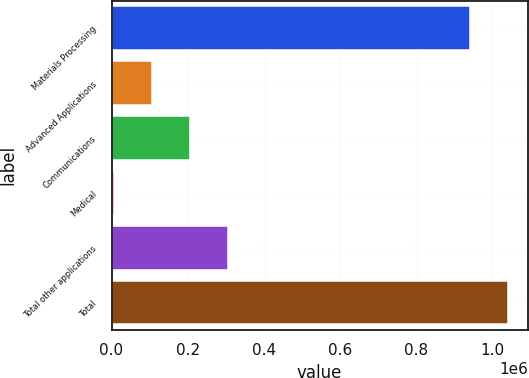Convert chart. <chart><loc_0><loc_0><loc_500><loc_500><bar_chart><fcel>Materials Processing<fcel>Advanced Applications<fcel>Communications<fcel>Medical<fcel>Total other applications<fcel>Total<nl><fcel>942119<fcel>106976<fcel>206887<fcel>7065<fcel>306797<fcel>1.04203e+06<nl></chart> 